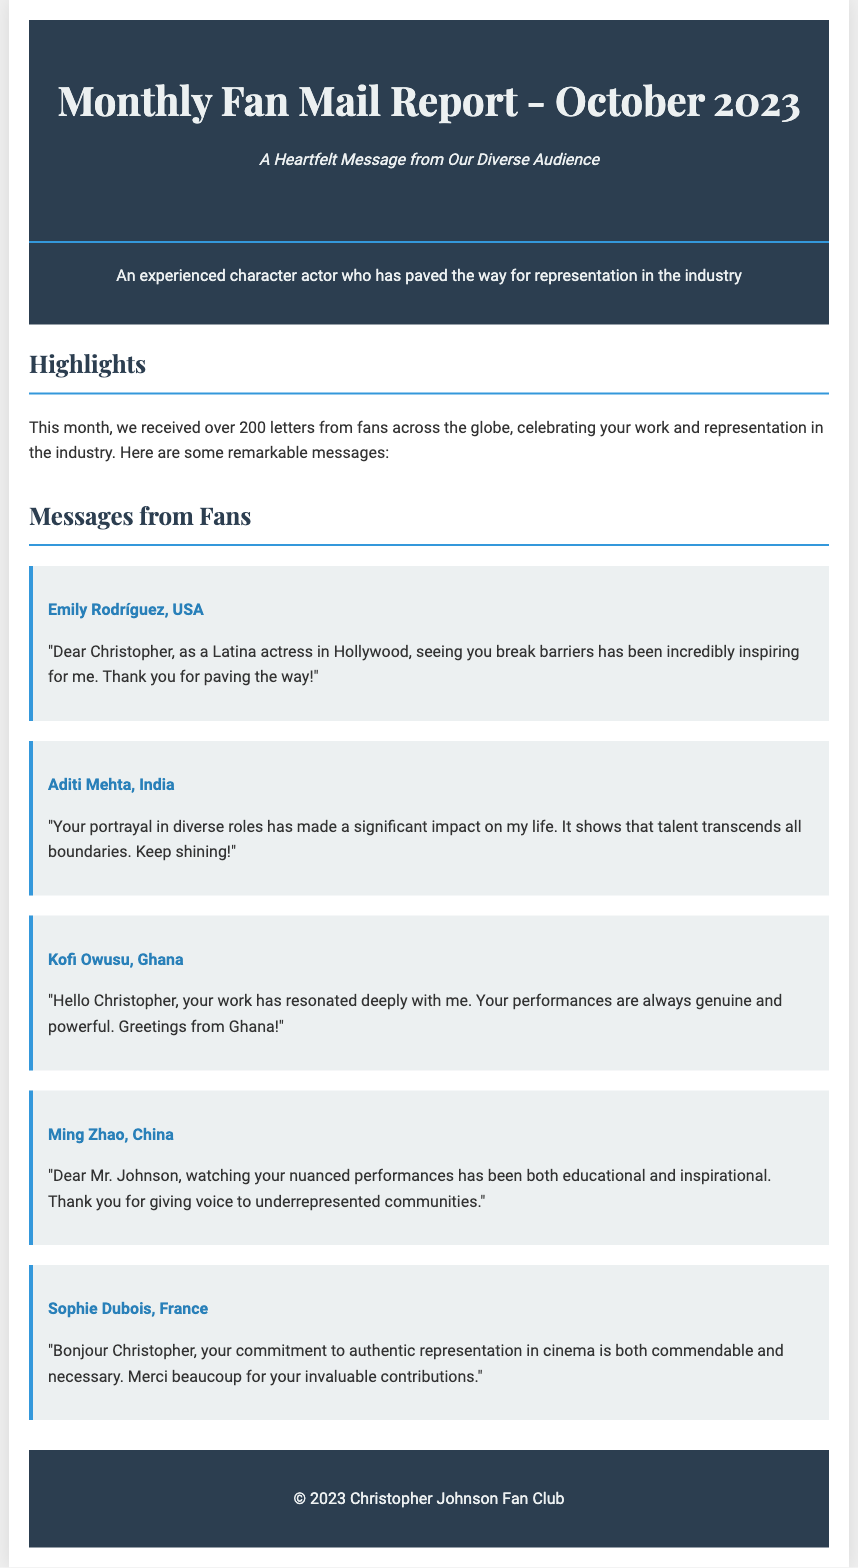What is the total number of letters received this month? The document states that over 200 letters were received from fans.
Answer: over 200 Who is the main subject of the report? The report highlights Christopher Johnson as the main subject.
Answer: Christopher Johnson Which country is Emily Rodríguez from? The document indicates that Emily Rodríguez is from the USA.
Answer: USA What is the tagline of the report? The tagline is stated as "A Heartfelt Message from Our Diverse Audience".
Answer: A Heartfelt Message from Our Diverse Audience What is emphasized in Aditi Mehta's message? Aditi Mehta's message underscores the impact of Christopher's diverse roles.
Answer: Impact of diverse roles Who expressed gratitude for authentic representation in cinema? Sophie Dubois expressed gratitude for this aspect in cinema.
Answer: Sophie Dubois How many highlights are presented in the report? The document mentions that there are highlights and lists multiple messages, indicating a focus on them, but does not explicitly count them.
Answer: Multiple messages What color is used for the header background? The header's background color is specified as #2c3e50.
Answer: #2c3e50 Which continent is represented by Kofi Owusu? Kofi Owusu is from Ghana, which is in Africa.
Answer: Africa 